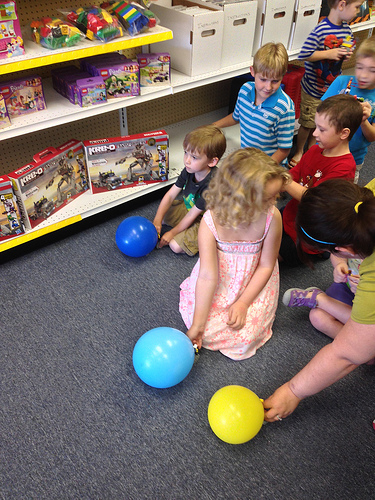<image>
Is there a box under the blocks? Yes. The box is positioned underneath the blocks, with the blocks above it in the vertical space. Where is the girl in relation to the boy? Is it in front of the boy? Yes. The girl is positioned in front of the boy, appearing closer to the camera viewpoint. 